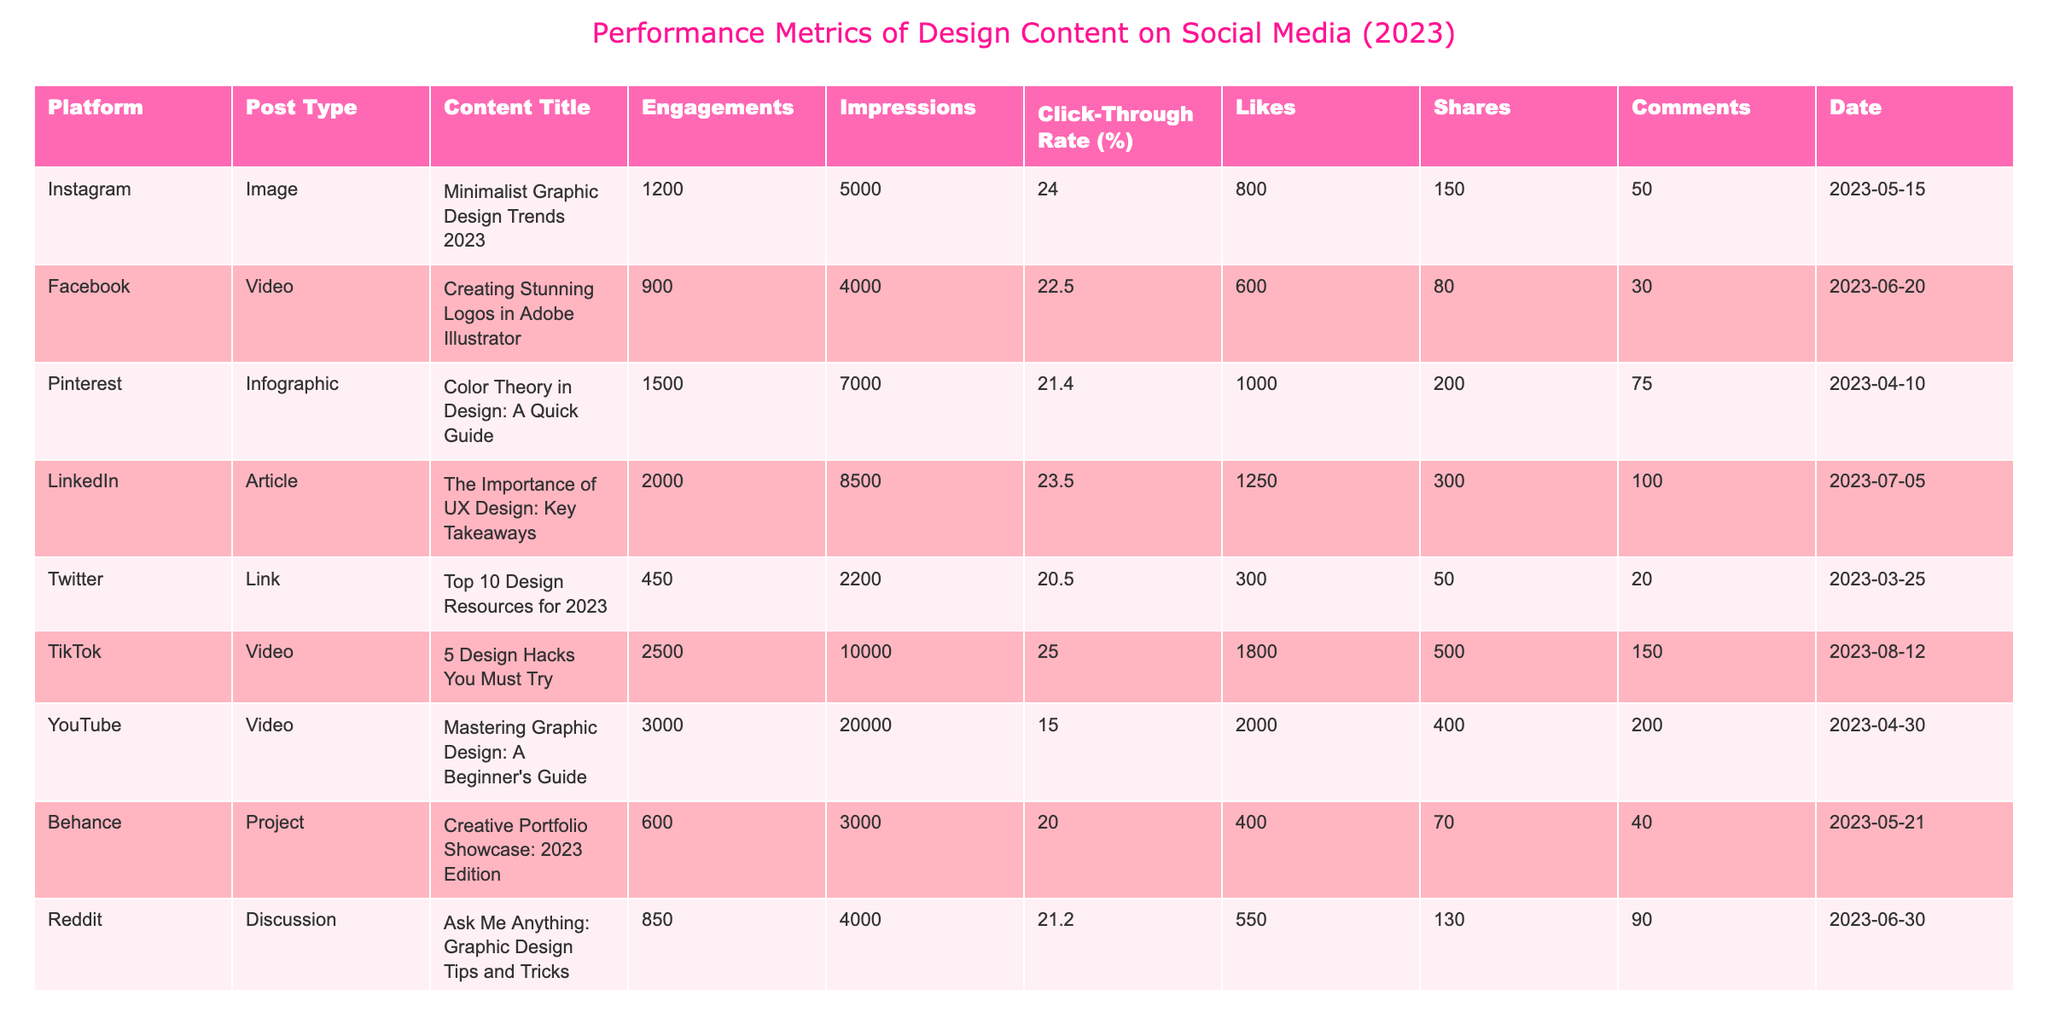What platform had the highest engagements for design content in 2023? By reviewing the "Engagements" column, TikTok has the highest number at 2500.
Answer: TikTok What is the click-through rate of the post titled "Creating Stunning Logos in Adobe Illustrator"? The "Click-Through Rate (%)" for this post on Facebook is 22.5%.
Answer: 22.5% Which post type had the most total likes across all platforms? By summing the likes for each post type, videos had 600 (Facebook) + 1800 (TikTok) + 2000 (YouTube) = 4400 likes, while images displayed 800 (Instagram) and projects added 400 (Behance) for 1200 likes in total, indicating videos had the highest total.
Answer: Videos What is the average click-through rate of all the posts listed? Calculating the average, we sum all click-through rates: (24.0 + 22.5 + 21.4 + 23.5 + 20.5 + 25.0 + 15.0 + 20.0 + 21.2 + 19.0) =  212.1 across 10 posts, so the average is 212.1/10 = 21.21%.
Answer: 21.21% Did the post titled "Color Theory in Design: A Quick Guide" receive more engagements than the total engagements of posts on LinkedIn and Reddit combined? The engagements for "Color Theory in Design: A Quick Guide" is 1500. The combined engagements for LinkedIn and Reddit are 2000 + 850 = 2850. Therefore, 1500 is less than 2850.
Answer: No Which content type had the highest impressions and how many? The "Impressions" for the YouTube post titled "Mastering Graphic Design: A Beginner's Guide" is 20000, which is the highest across all content types.
Answer: Video, 20000 If you compare the total likes of Instagram and Pinterest, which one had more likes? Instagram has 800 likes, while Pinterest has 1000 likes. Since 1000 (Pinterest) is greater than 800 (Instagram), Pinterest has more likes.
Answer: Pinterest What was the difference in impressions between TikTok and Twitter? TikTok had 10000 impressions while Twitter had 2200 impressions. The difference is 10000 - 2200 = 7800 impressions.
Answer: 7800 Is the engagement for "Ask Me Anything: Graphic Design Tips and Tricks" greater than the average engagement of all posts? The engagement for the Reddit post is 850. The average engagement can be calculated as follows: (1200 + 900 + 1500 + 2000 + 450 + 2500 + 3000 + 600 + 850 + 700) = 9750 across 10 posts, giving an average of 9750/10 = 975. Since 850 is less than 975, the answer is no.
Answer: No What is the total number of comments for the post with the least engagements? The post with the least engagements is "Top 10 Design Resources for 2023" on Twitter with 450 engagements and it has 20 comments.
Answer: 20 